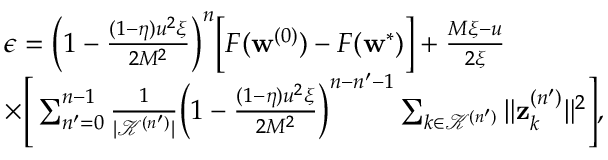Convert formula to latex. <formula><loc_0><loc_0><loc_500><loc_500>\begin{array} { r l } & { \epsilon = \left ( 1 - \frac { ( 1 - \eta ) u ^ { 2 } \xi } { 2 M ^ { 2 } } \right ) ^ { n } \left [ F ( w ^ { ( 0 ) } ) - F ( w ^ { * } ) \right ] + \frac { M \xi - u } { 2 \xi } } \\ & { \times \left [ \sum _ { n ^ { \prime } = 0 } ^ { n - 1 } \frac { 1 } { | \mathcal { K } ^ { ( n ^ { \prime } ) } | } \left ( 1 - \frac { ( 1 - \eta ) u ^ { 2 } \xi } { 2 M ^ { 2 } } \right ) ^ { n - n ^ { \prime } - 1 } \sum _ { k \in \mathcal { K } ^ { ( n ^ { \prime } ) } } \| z _ { k } ^ { ( n ^ { \prime } ) } \| ^ { 2 } \right ] , } \end{array}</formula> 